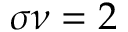<formula> <loc_0><loc_0><loc_500><loc_500>\sigma \nu = 2</formula> 